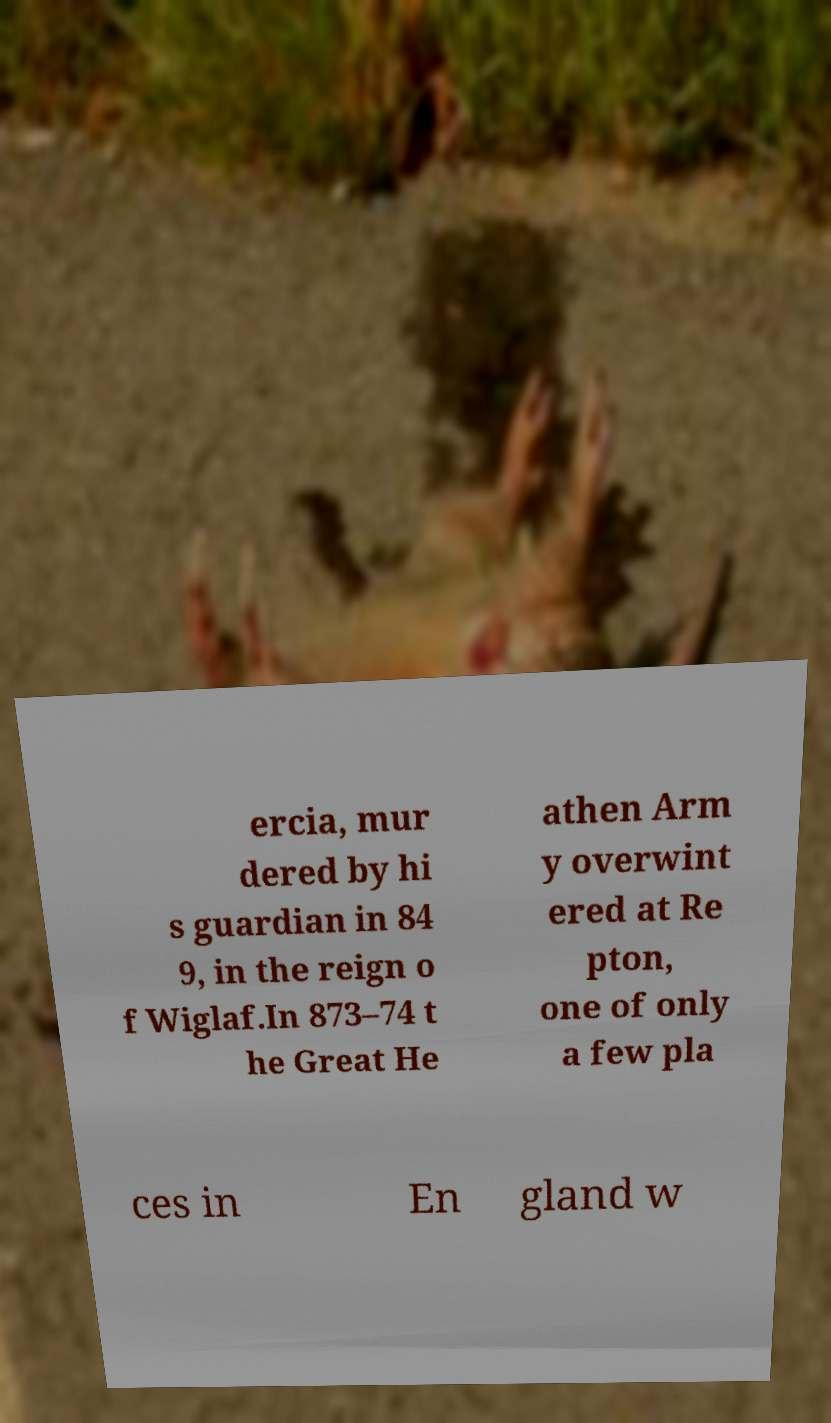Can you accurately transcribe the text from the provided image for me? ercia, mur dered by hi s guardian in 84 9, in the reign o f Wiglaf.In 873–74 t he Great He athen Arm y overwint ered at Re pton, one of only a few pla ces in En gland w 